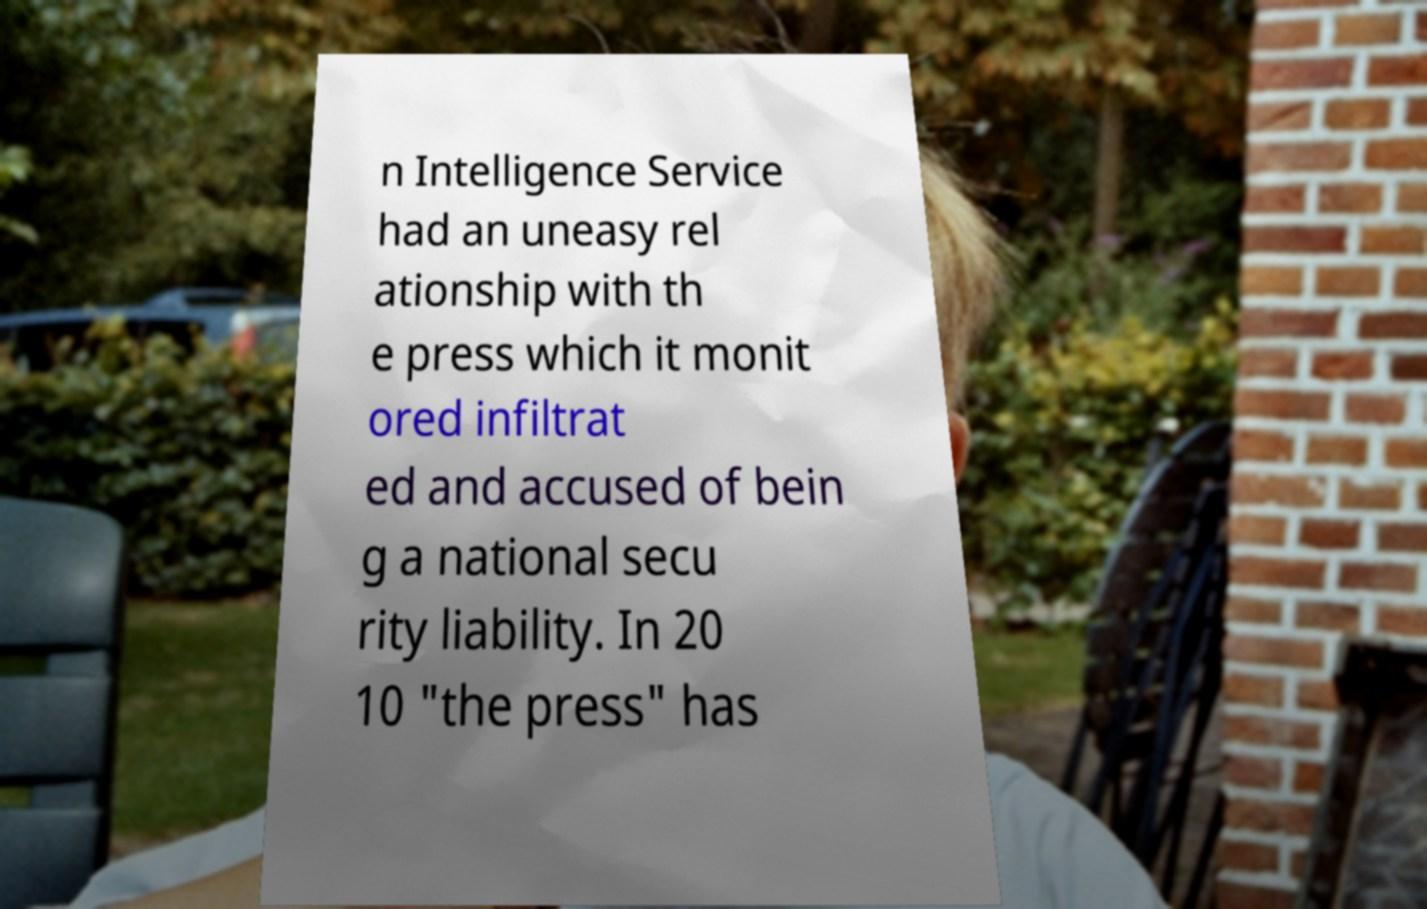What messages or text are displayed in this image? I need them in a readable, typed format. n Intelligence Service had an uneasy rel ationship with th e press which it monit ored infiltrat ed and accused of bein g a national secu rity liability. In 20 10 "the press" has 